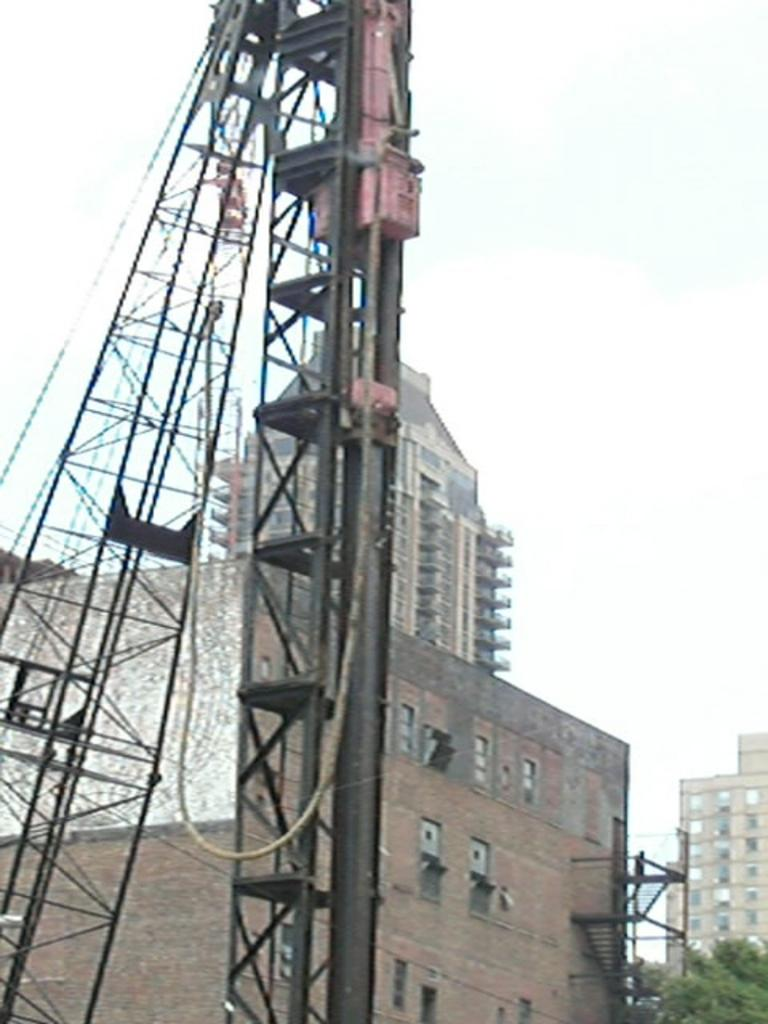What is the main structure in the image? There is a tower in the image. What else can be seen in the background of the image? There are buildings and trees with green color in the background of the image. How would you describe the sky in the image? The sky is white in color in the image. Can you hear the men crying in the image? There are no men or any sounds mentioned in the image, so it's not possible to determine if anyone is crying. 